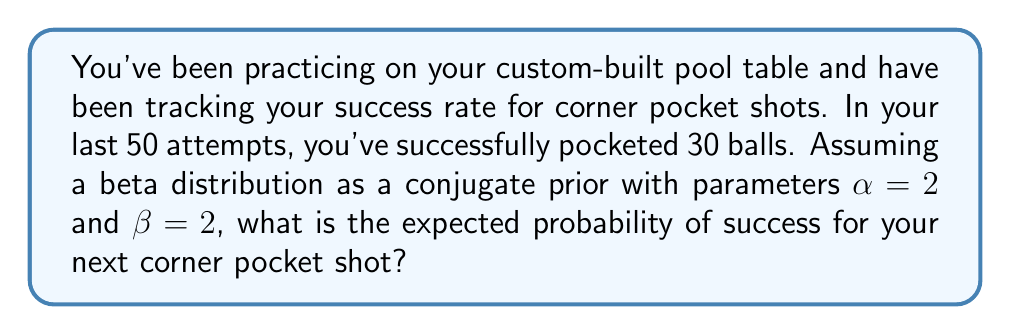Show me your answer to this math problem. To solve this problem, we'll use Bayesian inference with a beta-binomial model. The beta distribution is a conjugate prior for the binomial distribution, which makes it convenient for updating our beliefs about the probability of success.

1) We start with a prior beta distribution with parameters $\alpha=2$ and $\beta=2$. This represents our initial belief about the probability of success before observing any data.

2) We then observe 30 successes out of 50 attempts. In Bayesian terms, this is our likelihood.

3) The posterior distribution is also a beta distribution, with updated parameters:

   $\alpha_{posterior} = \alpha_{prior} + \text{successes} = 2 + 30 = 32$
   $\beta_{posterior} = \beta_{prior} + \text{failures} = 2 + (50-30) = 22$

4) The expected value (mean) of a beta distribution with parameters $\alpha$ and $\beta$ is given by:

   $$E[X] = \frac{\alpha}{\alpha + \beta}$$

5) Substituting our posterior parameters:

   $$E[X] = \frac{32}{32 + 22} = \frac{32}{54}$$

6) Simplifying:

   $$E[X] = \frac{16}{27} \approx 0.5926$$

This means that based on your prior beliefs and observed data, the expected probability of success for your next corner pocket shot is approximately 0.5926 or about 59.26%.
Answer: $\frac{16}{27}$ or approximately $0.5926$ 